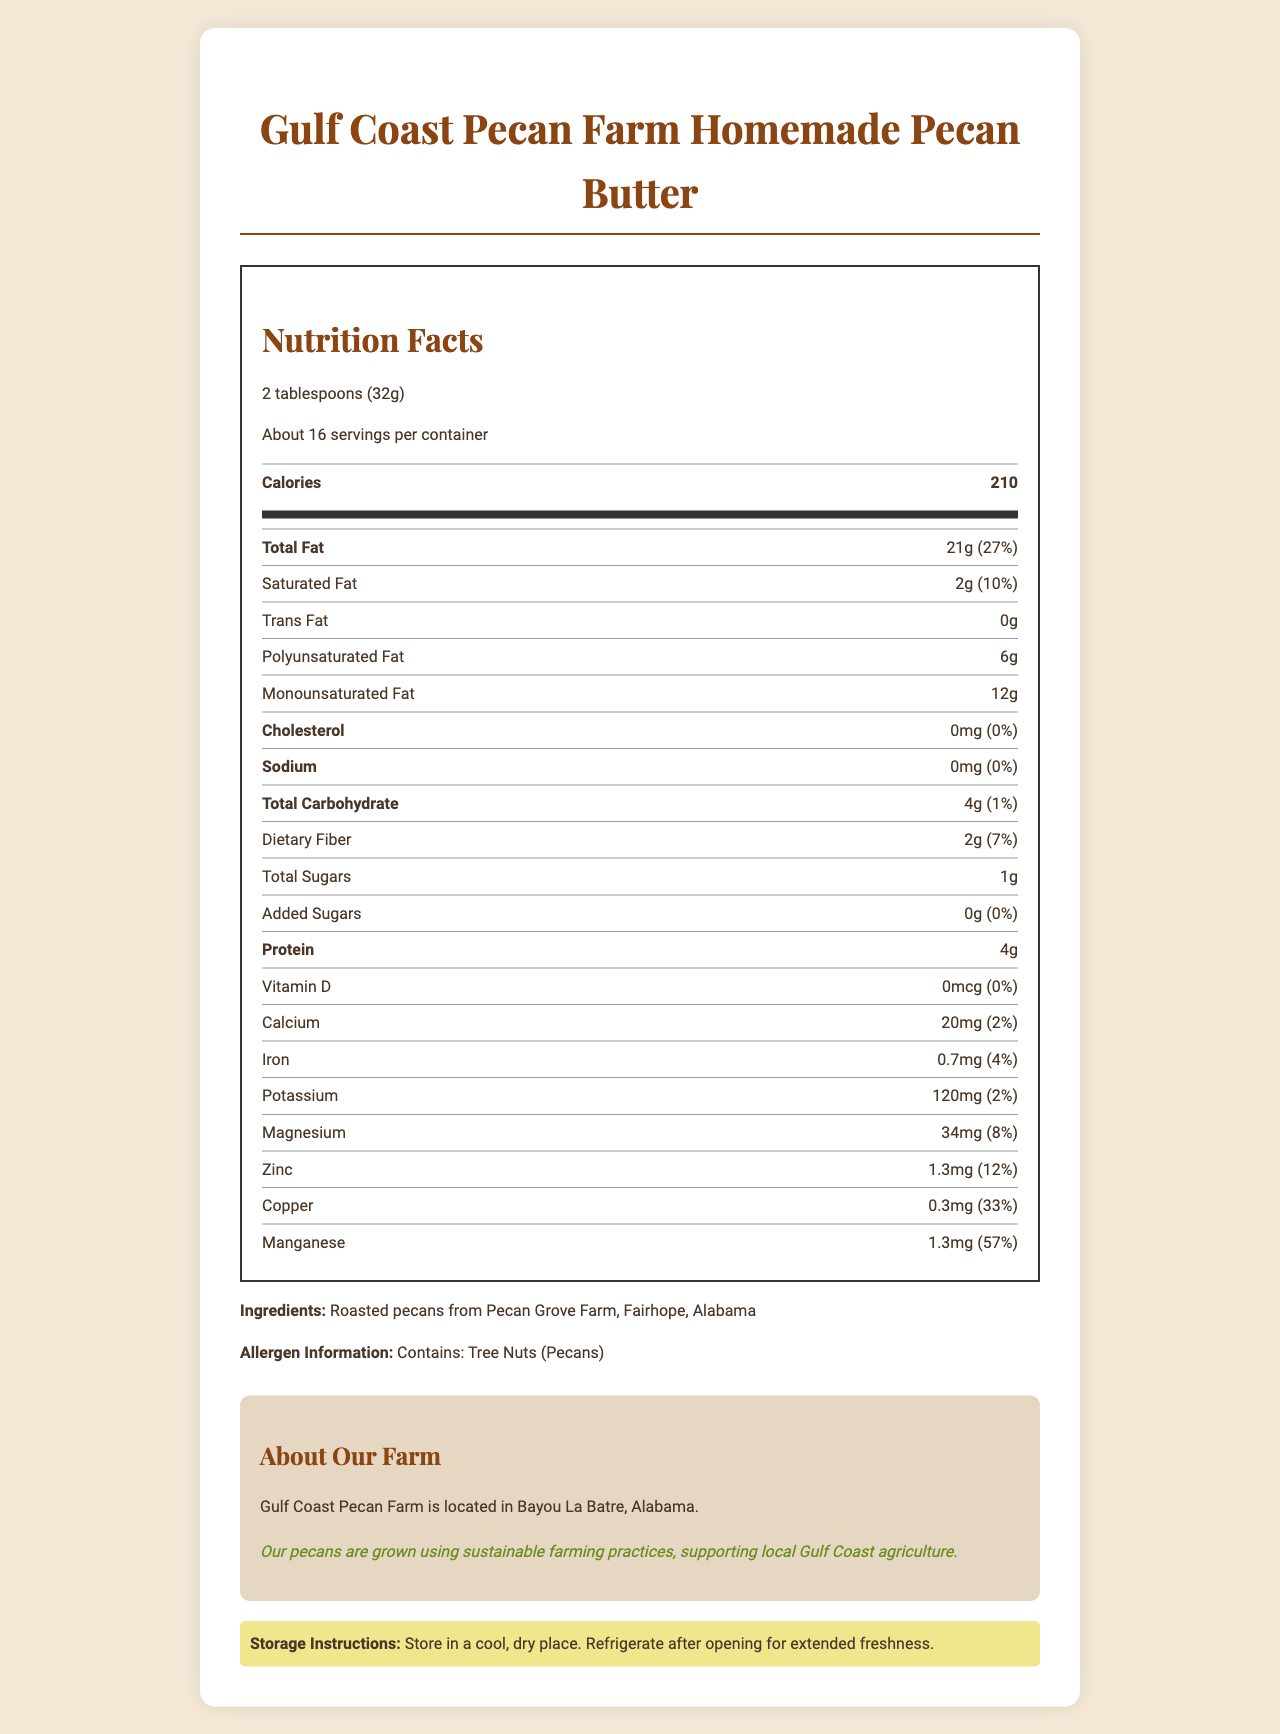what is the serving size? The serving size is stated directly in the document under the Nutrition Facts section.
Answer: 2 tablespoons (32g) how many calories are in one serving? The document lists the caloric content as 210 calories per serving.
Answer: 210 how much total fat is in one serving, and what percentage of the daily value does it represent? The document indicates one serving contains 21 grams of total fat, which is 27% of the daily value.
Answer: 21g, 27% which mineral provides the highest daily value percentage per serving? Manganese provides 57% of the daily value per serving, which is higher than any other mineral listed.
Answer: Manganese what is the amount of added sugars in each serving? The document specifies that the added sugars amount per serving is 0 grams.
Answer: 0g how many servings are in each container? A. 15 B. About 16 C. 20 D. About 12 The document mentions there are "About 16" servings per container.
Answer: B which vitamin or mineral has a 0% daily value per serving? A. Vitamin D B. Calcium C. Iron D. Zinc The document shows that Vitamin D has 0% of the daily value per serving.
Answer: A does the pecan butter contain any trans fat? The document states that the trans fat content is 0g per serving.
Answer: No summarize the storage instructions for the pecan butter. The storage instructions are divided into two main points: store in a cool, dry place, and refrigerate after opening for extended freshness.
Answer: Store in a cool, dry place; Refrigerate after opening for extended freshness. how much protein is in one serving? The document shows that each serving contains 4 grams of protein.
Answer: 4g where is the Gulf Coast Pecan Farm located? The document mentions that the farm is located in Bayou La Batre, Alabama.
Answer: Bayou La Batre, Alabama does this pecan butter contain any tree nuts? The allergen statement in the document indicates it contains tree nuts (pecans).
Answer: Yes what is the main idea of this document? The main sections of the document include Nutrition Facts, Ingredients, Allergen Information, Farm Information, Sustainability Note, and Storage Instructions, which collectively offer a comprehensive overview of the pecan butter product.
Answer: The document provides detailed nutrition facts for homemade pecan butter from Gulf Coast Pecan Farm, including serving size, nutritional content, ingredients, allergen information, farm details, sustainability practices, and storage instructions. how are the pecans grown at Gulf Coast Pecan Farm? The document states that their pecans are grown using sustainable farming practices.
Answer: Using sustainable farming practices what is the total carbohydrate content and its daily value percentage in one serving? The total carbohydrate content per serving is 4 grams, which is 1% of the daily value.
Answer: 4g, 1% how much copper and its daily value percentage are in one serving? The document indicates that each serving has 0.3mg of copper, which is 33% of the daily value.
Answer: 0.3mg, 33% what is the name of the farm that produces the pecans for this pecan butter? The document states that the pecans come from Gulf Coast Pecan Farm.
Answer: Gulf Coast Pecan Farm how many grams of monounsaturated fat are in one serving? The document lists 12 grams of monounsaturated fat per serving.
Answer: 12g what is the percentage of daily value for dietary fiber per serving? The document shows that dietary fiber comprises 7% of the daily value per serving.
Answer: 7% what is the cholesterol content and its daily value percentage in one serving? The document indicates there is no cholesterol in one serving, with a 0% daily value.
Answer: 0mg, 0% 